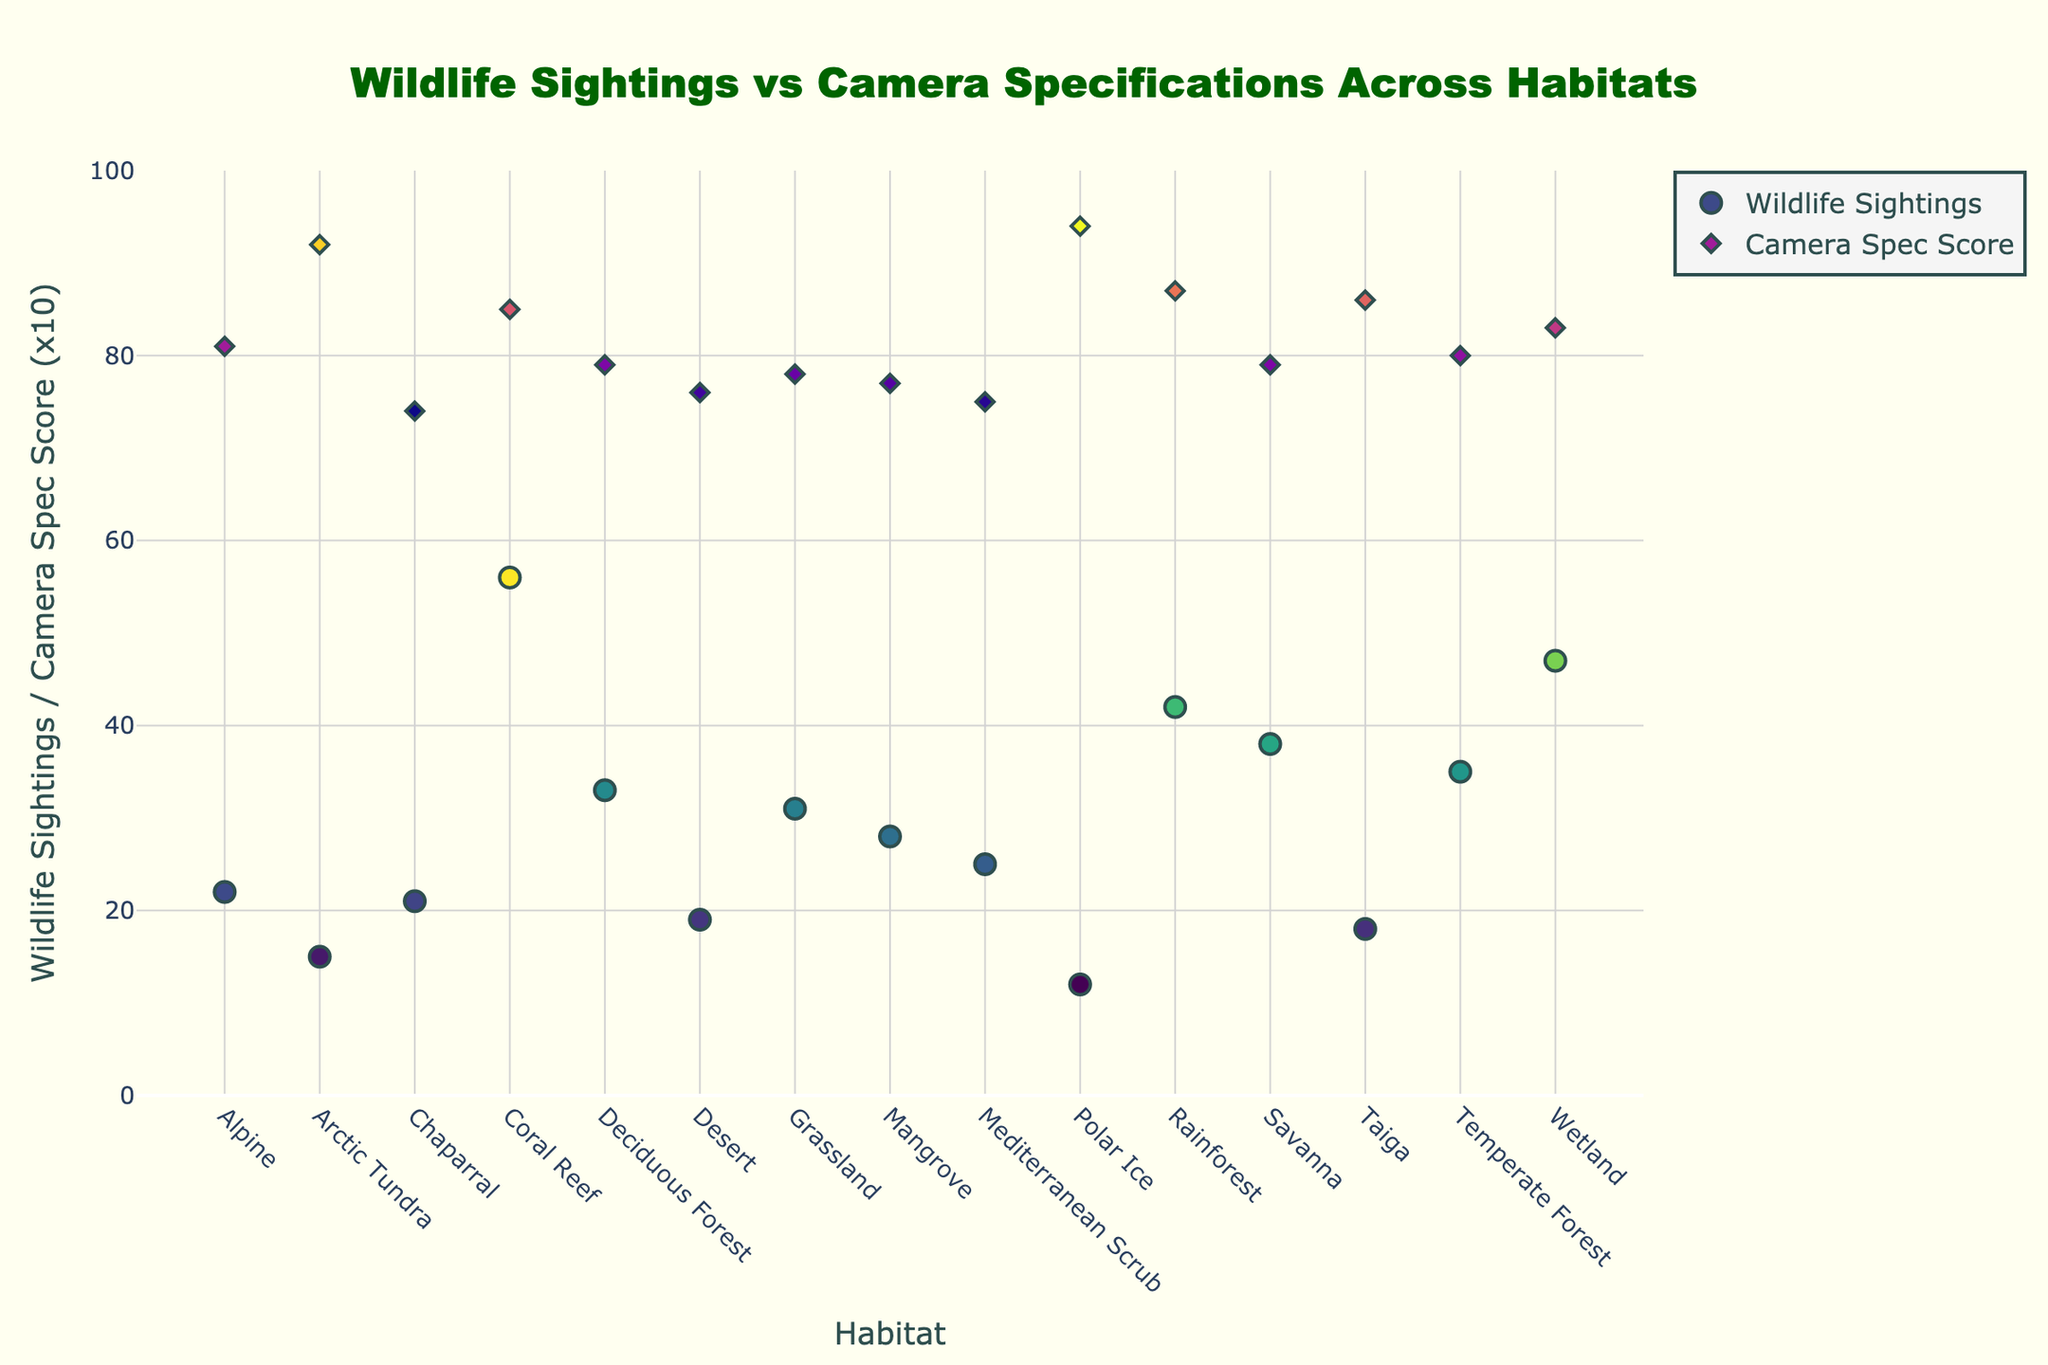What is the title of the plot? The title is usually displayed at the top of the plot. In this case, the title of the plot is "Wildlife Sightings vs Camera Specifications Across Habitats", which is clearly mentioned in the plot creation code.
Answer: Wildlife Sightings vs Camera Specifications Across Habitats What does the y-axis represent? By looking at the y-axis label in the figure, we can see that it represents "Wildlife Sightings / Camera Spec Score (x10)". This means one set of points shows the number of wildlife sightings, and the other set, scaled by a factor of 10, shows the camera specification scores.
Answer: Wildlife Sightings / Camera Spec Score (x10) Which habitat has the highest number of wildlife sightings? To determine this, we look at the highest point in the 'Wildlife Sightings' trace. From the figure, the Coral Reef habitat has the highest number of wildlife sightings.
Answer: Coral Reef What is the range of camera spec scores across the habitats? By examining the colored points associated with the Camera Spec Score, scaled up by 10 for visibility, the camera spec scores range from 7.4 to 9.4 based on our provided dataset.
Answer: 7.4 to 9.4 Which two habitats have the closest camera spec scores? We need to visually inspect the Camera Spec Score points that are closest on the y-axis. Based on the figure, Rainforest and Taiga have very close camera spec scores.
Answer: Rainforest and Taiga What is the average number of wildlife sightings across all habitats? To calculate this, sum all wildlife sightings and divide by the number of habitats: (42 + 38 + 15 + 56 + 22 + 19 + 31 + 47 + 35 + 28 + 18 + 25 + 12 + 33 + 21) = 442. There are 15 habitats, so the average is 442 / 15 = 29.47.
Answer: 29.47 Which habitat in the top three for wildlife sightings has the highest camera spec score? First, identify the top three habitats with the highest wildlife sightings: Coral Reef, Wetland, and Rainforest. Then, check their camera spec scores: Coral Reef (8.5), Wetland (8.3), Rainforest (8.7). Rainforest has the highest camera spec score among them.
Answer: Rainforest Is there a general trend between wildlife sightings and camera spec score across habitats? By observing the general spread and pattern of points in the plot, we can see if higher wildlife sightings correlate with higher camera spec scores or vice versa. There is no clear increasing or decreasing trend visible in the figure, indicating no strong correlation.
Answer: No strong correlation 